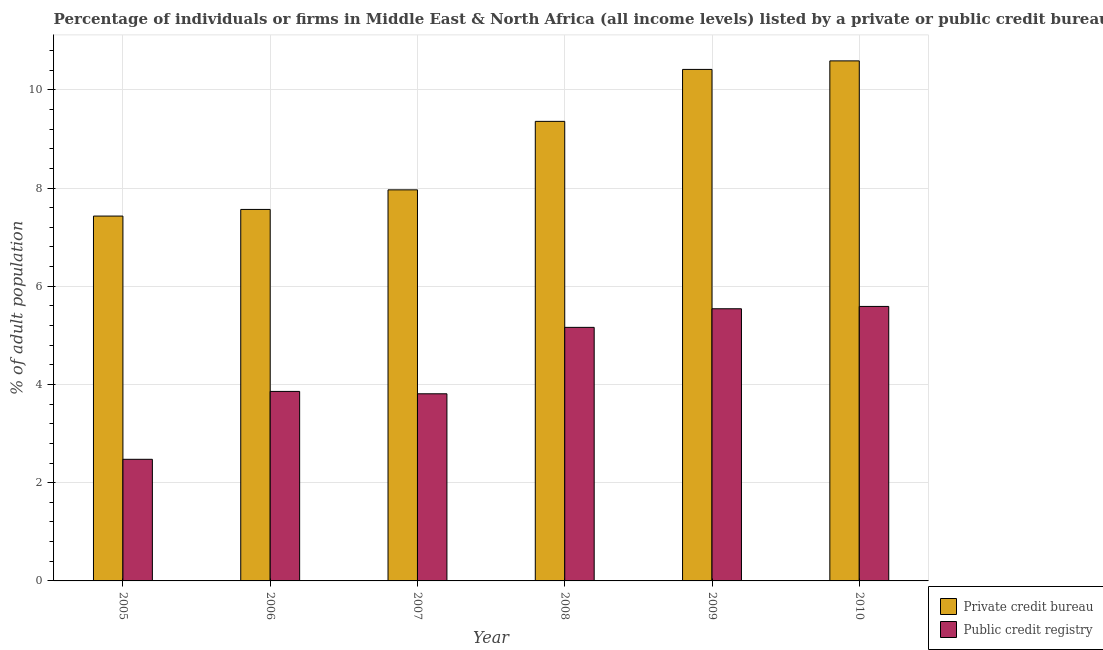How many different coloured bars are there?
Ensure brevity in your answer.  2. How many bars are there on the 6th tick from the left?
Your response must be concise. 2. How many bars are there on the 2nd tick from the right?
Provide a succinct answer. 2. What is the percentage of firms listed by private credit bureau in 2008?
Provide a short and direct response. 9.36. Across all years, what is the maximum percentage of firms listed by private credit bureau?
Provide a succinct answer. 10.59. Across all years, what is the minimum percentage of firms listed by public credit bureau?
Give a very brief answer. 2.48. In which year was the percentage of firms listed by private credit bureau minimum?
Your answer should be compact. 2005. What is the total percentage of firms listed by private credit bureau in the graph?
Keep it short and to the point. 53.32. What is the difference between the percentage of firms listed by private credit bureau in 2005 and that in 2006?
Make the answer very short. -0.14. What is the difference between the percentage of firms listed by private credit bureau in 2008 and the percentage of firms listed by public credit bureau in 2010?
Give a very brief answer. -1.23. What is the average percentage of firms listed by private credit bureau per year?
Offer a very short reply. 8.89. In how many years, is the percentage of firms listed by private credit bureau greater than 0.8 %?
Provide a succinct answer. 6. What is the ratio of the percentage of firms listed by private credit bureau in 2007 to that in 2009?
Offer a terse response. 0.76. Is the difference between the percentage of firms listed by private credit bureau in 2007 and 2009 greater than the difference between the percentage of firms listed by public credit bureau in 2007 and 2009?
Keep it short and to the point. No. What is the difference between the highest and the second highest percentage of firms listed by public credit bureau?
Your answer should be very brief. 0.05. What is the difference between the highest and the lowest percentage of firms listed by public credit bureau?
Provide a succinct answer. 3.11. Is the sum of the percentage of firms listed by private credit bureau in 2006 and 2010 greater than the maximum percentage of firms listed by public credit bureau across all years?
Your answer should be very brief. Yes. What does the 1st bar from the left in 2010 represents?
Make the answer very short. Private credit bureau. What does the 2nd bar from the right in 2006 represents?
Your answer should be compact. Private credit bureau. How many bars are there?
Ensure brevity in your answer.  12. How many years are there in the graph?
Your answer should be very brief. 6. Are the values on the major ticks of Y-axis written in scientific E-notation?
Your answer should be compact. No. Does the graph contain grids?
Make the answer very short. Yes. What is the title of the graph?
Provide a succinct answer. Percentage of individuals or firms in Middle East & North Africa (all income levels) listed by a private or public credit bureau. What is the label or title of the X-axis?
Your answer should be compact. Year. What is the label or title of the Y-axis?
Make the answer very short. % of adult population. What is the % of adult population in Private credit bureau in 2005?
Offer a very short reply. 7.43. What is the % of adult population of Public credit registry in 2005?
Your answer should be very brief. 2.48. What is the % of adult population in Private credit bureau in 2006?
Keep it short and to the point. 7.56. What is the % of adult population of Public credit registry in 2006?
Make the answer very short. 3.86. What is the % of adult population of Private credit bureau in 2007?
Your response must be concise. 7.96. What is the % of adult population of Public credit registry in 2007?
Provide a succinct answer. 3.81. What is the % of adult population of Private credit bureau in 2008?
Make the answer very short. 9.36. What is the % of adult population of Public credit registry in 2008?
Provide a short and direct response. 5.16. What is the % of adult population in Private credit bureau in 2009?
Give a very brief answer. 10.42. What is the % of adult population in Public credit registry in 2009?
Your answer should be very brief. 5.54. What is the % of adult population of Private credit bureau in 2010?
Offer a terse response. 10.59. What is the % of adult population of Public credit registry in 2010?
Offer a terse response. 5.59. Across all years, what is the maximum % of adult population of Private credit bureau?
Give a very brief answer. 10.59. Across all years, what is the maximum % of adult population in Public credit registry?
Make the answer very short. 5.59. Across all years, what is the minimum % of adult population of Private credit bureau?
Keep it short and to the point. 7.43. Across all years, what is the minimum % of adult population of Public credit registry?
Give a very brief answer. 2.48. What is the total % of adult population in Private credit bureau in the graph?
Make the answer very short. 53.32. What is the total % of adult population of Public credit registry in the graph?
Make the answer very short. 26.44. What is the difference between the % of adult population of Private credit bureau in 2005 and that in 2006?
Keep it short and to the point. -0.14. What is the difference between the % of adult population in Public credit registry in 2005 and that in 2006?
Your response must be concise. -1.38. What is the difference between the % of adult population of Private credit bureau in 2005 and that in 2007?
Offer a terse response. -0.53. What is the difference between the % of adult population in Public credit registry in 2005 and that in 2007?
Your answer should be very brief. -1.33. What is the difference between the % of adult population of Private credit bureau in 2005 and that in 2008?
Ensure brevity in your answer.  -1.93. What is the difference between the % of adult population in Public credit registry in 2005 and that in 2008?
Your answer should be very brief. -2.69. What is the difference between the % of adult population of Private credit bureau in 2005 and that in 2009?
Provide a short and direct response. -2.99. What is the difference between the % of adult population of Public credit registry in 2005 and that in 2009?
Your answer should be compact. -3.07. What is the difference between the % of adult population in Private credit bureau in 2005 and that in 2010?
Give a very brief answer. -3.16. What is the difference between the % of adult population of Public credit registry in 2005 and that in 2010?
Ensure brevity in your answer.  -3.11. What is the difference between the % of adult population of Private credit bureau in 2006 and that in 2007?
Keep it short and to the point. -0.4. What is the difference between the % of adult population in Public credit registry in 2006 and that in 2007?
Offer a very short reply. 0.05. What is the difference between the % of adult population in Private credit bureau in 2006 and that in 2008?
Ensure brevity in your answer.  -1.79. What is the difference between the % of adult population of Public credit registry in 2006 and that in 2008?
Provide a short and direct response. -1.3. What is the difference between the % of adult population of Private credit bureau in 2006 and that in 2009?
Ensure brevity in your answer.  -2.85. What is the difference between the % of adult population of Public credit registry in 2006 and that in 2009?
Your response must be concise. -1.68. What is the difference between the % of adult population of Private credit bureau in 2006 and that in 2010?
Offer a very short reply. -3.02. What is the difference between the % of adult population of Public credit registry in 2006 and that in 2010?
Your answer should be compact. -1.73. What is the difference between the % of adult population in Private credit bureau in 2007 and that in 2008?
Make the answer very short. -1.39. What is the difference between the % of adult population of Public credit registry in 2007 and that in 2008?
Make the answer very short. -1.35. What is the difference between the % of adult population in Private credit bureau in 2007 and that in 2009?
Offer a terse response. -2.45. What is the difference between the % of adult population in Public credit registry in 2007 and that in 2009?
Provide a short and direct response. -1.73. What is the difference between the % of adult population in Private credit bureau in 2007 and that in 2010?
Your response must be concise. -2.63. What is the difference between the % of adult population in Public credit registry in 2007 and that in 2010?
Offer a very short reply. -1.78. What is the difference between the % of adult population in Private credit bureau in 2008 and that in 2009?
Keep it short and to the point. -1.06. What is the difference between the % of adult population in Public credit registry in 2008 and that in 2009?
Keep it short and to the point. -0.38. What is the difference between the % of adult population of Private credit bureau in 2008 and that in 2010?
Your answer should be very brief. -1.23. What is the difference between the % of adult population of Public credit registry in 2008 and that in 2010?
Make the answer very short. -0.43. What is the difference between the % of adult population in Private credit bureau in 2009 and that in 2010?
Your answer should be compact. -0.17. What is the difference between the % of adult population in Public credit registry in 2009 and that in 2010?
Ensure brevity in your answer.  -0.05. What is the difference between the % of adult population of Private credit bureau in 2005 and the % of adult population of Public credit registry in 2006?
Offer a terse response. 3.57. What is the difference between the % of adult population in Private credit bureau in 2005 and the % of adult population in Public credit registry in 2007?
Make the answer very short. 3.62. What is the difference between the % of adult population in Private credit bureau in 2005 and the % of adult population in Public credit registry in 2008?
Ensure brevity in your answer.  2.27. What is the difference between the % of adult population of Private credit bureau in 2005 and the % of adult population of Public credit registry in 2009?
Offer a terse response. 1.89. What is the difference between the % of adult population of Private credit bureau in 2005 and the % of adult population of Public credit registry in 2010?
Provide a short and direct response. 1.84. What is the difference between the % of adult population in Private credit bureau in 2006 and the % of adult population in Public credit registry in 2007?
Your answer should be very brief. 3.75. What is the difference between the % of adult population in Private credit bureau in 2006 and the % of adult population in Public credit registry in 2008?
Your answer should be compact. 2.4. What is the difference between the % of adult population in Private credit bureau in 2006 and the % of adult population in Public credit registry in 2009?
Provide a succinct answer. 2.02. What is the difference between the % of adult population of Private credit bureau in 2006 and the % of adult population of Public credit registry in 2010?
Keep it short and to the point. 1.98. What is the difference between the % of adult population in Private credit bureau in 2007 and the % of adult population in Public credit registry in 2008?
Provide a short and direct response. 2.8. What is the difference between the % of adult population of Private credit bureau in 2007 and the % of adult population of Public credit registry in 2009?
Your answer should be compact. 2.42. What is the difference between the % of adult population in Private credit bureau in 2007 and the % of adult population in Public credit registry in 2010?
Give a very brief answer. 2.37. What is the difference between the % of adult population in Private credit bureau in 2008 and the % of adult population in Public credit registry in 2009?
Offer a very short reply. 3.82. What is the difference between the % of adult population in Private credit bureau in 2008 and the % of adult population in Public credit registry in 2010?
Your answer should be compact. 3.77. What is the difference between the % of adult population of Private credit bureau in 2009 and the % of adult population of Public credit registry in 2010?
Ensure brevity in your answer.  4.83. What is the average % of adult population in Private credit bureau per year?
Offer a very short reply. 8.89. What is the average % of adult population of Public credit registry per year?
Make the answer very short. 4.41. In the year 2005, what is the difference between the % of adult population in Private credit bureau and % of adult population in Public credit registry?
Offer a very short reply. 4.95. In the year 2006, what is the difference between the % of adult population in Private credit bureau and % of adult population in Public credit registry?
Give a very brief answer. 3.71. In the year 2007, what is the difference between the % of adult population of Private credit bureau and % of adult population of Public credit registry?
Offer a very short reply. 4.15. In the year 2008, what is the difference between the % of adult population of Private credit bureau and % of adult population of Public credit registry?
Ensure brevity in your answer.  4.19. In the year 2009, what is the difference between the % of adult population of Private credit bureau and % of adult population of Public credit registry?
Provide a short and direct response. 4.87. What is the ratio of the % of adult population of Private credit bureau in 2005 to that in 2006?
Your response must be concise. 0.98. What is the ratio of the % of adult population in Public credit registry in 2005 to that in 2006?
Offer a terse response. 0.64. What is the ratio of the % of adult population of Private credit bureau in 2005 to that in 2007?
Offer a very short reply. 0.93. What is the ratio of the % of adult population in Public credit registry in 2005 to that in 2007?
Give a very brief answer. 0.65. What is the ratio of the % of adult population in Private credit bureau in 2005 to that in 2008?
Your answer should be very brief. 0.79. What is the ratio of the % of adult population in Public credit registry in 2005 to that in 2008?
Your answer should be compact. 0.48. What is the ratio of the % of adult population in Private credit bureau in 2005 to that in 2009?
Your response must be concise. 0.71. What is the ratio of the % of adult population in Public credit registry in 2005 to that in 2009?
Keep it short and to the point. 0.45. What is the ratio of the % of adult population of Private credit bureau in 2005 to that in 2010?
Provide a succinct answer. 0.7. What is the ratio of the % of adult population in Public credit registry in 2005 to that in 2010?
Make the answer very short. 0.44. What is the ratio of the % of adult population of Private credit bureau in 2006 to that in 2007?
Ensure brevity in your answer.  0.95. What is the ratio of the % of adult population of Public credit registry in 2006 to that in 2007?
Your answer should be compact. 1.01. What is the ratio of the % of adult population in Private credit bureau in 2006 to that in 2008?
Offer a terse response. 0.81. What is the ratio of the % of adult population in Public credit registry in 2006 to that in 2008?
Your answer should be very brief. 0.75. What is the ratio of the % of adult population in Private credit bureau in 2006 to that in 2009?
Ensure brevity in your answer.  0.73. What is the ratio of the % of adult population of Public credit registry in 2006 to that in 2009?
Your answer should be compact. 0.7. What is the ratio of the % of adult population in Private credit bureau in 2006 to that in 2010?
Offer a very short reply. 0.71. What is the ratio of the % of adult population of Public credit registry in 2006 to that in 2010?
Offer a very short reply. 0.69. What is the ratio of the % of adult population in Private credit bureau in 2007 to that in 2008?
Offer a terse response. 0.85. What is the ratio of the % of adult population in Public credit registry in 2007 to that in 2008?
Provide a succinct answer. 0.74. What is the ratio of the % of adult population of Private credit bureau in 2007 to that in 2009?
Your answer should be very brief. 0.76. What is the ratio of the % of adult population of Public credit registry in 2007 to that in 2009?
Offer a very short reply. 0.69. What is the ratio of the % of adult population in Private credit bureau in 2007 to that in 2010?
Keep it short and to the point. 0.75. What is the ratio of the % of adult population of Public credit registry in 2007 to that in 2010?
Provide a short and direct response. 0.68. What is the ratio of the % of adult population of Private credit bureau in 2008 to that in 2009?
Offer a terse response. 0.9. What is the ratio of the % of adult population of Public credit registry in 2008 to that in 2009?
Keep it short and to the point. 0.93. What is the ratio of the % of adult population in Private credit bureau in 2008 to that in 2010?
Offer a terse response. 0.88. What is the ratio of the % of adult population in Public credit registry in 2008 to that in 2010?
Make the answer very short. 0.92. What is the ratio of the % of adult population in Private credit bureau in 2009 to that in 2010?
Your answer should be very brief. 0.98. What is the ratio of the % of adult population of Public credit registry in 2009 to that in 2010?
Provide a succinct answer. 0.99. What is the difference between the highest and the second highest % of adult population of Private credit bureau?
Your answer should be compact. 0.17. What is the difference between the highest and the second highest % of adult population in Public credit registry?
Offer a very short reply. 0.05. What is the difference between the highest and the lowest % of adult population of Private credit bureau?
Your answer should be very brief. 3.16. What is the difference between the highest and the lowest % of adult population in Public credit registry?
Provide a succinct answer. 3.11. 